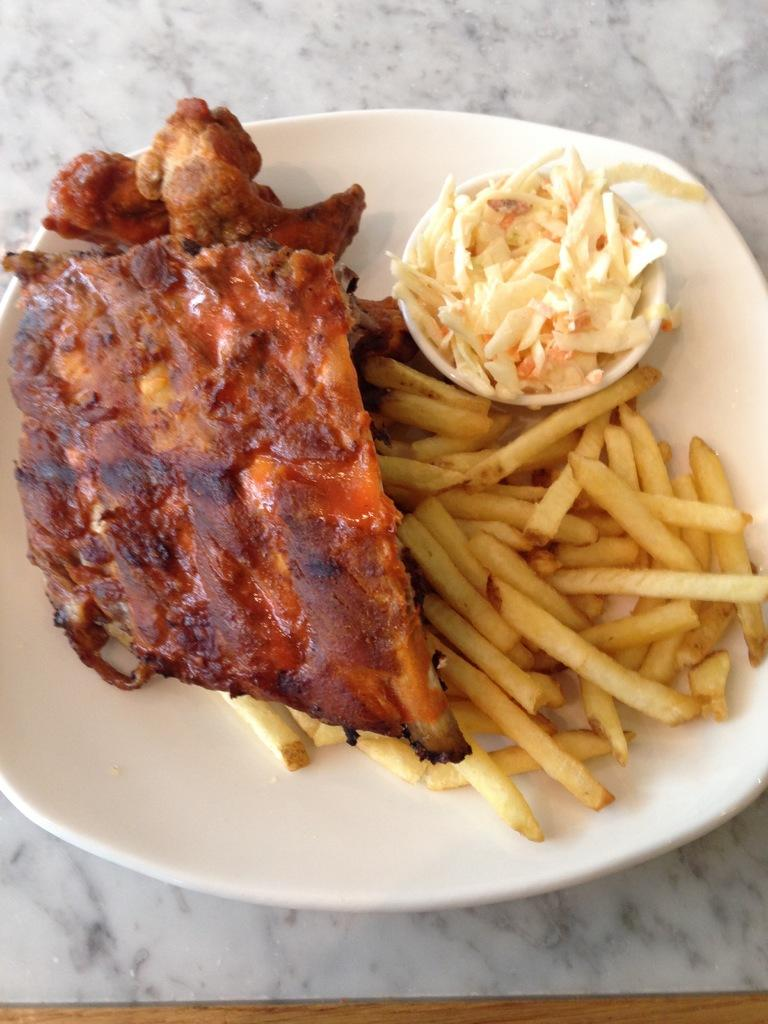What is located in the center of the image? There is a plate in the center of the image. What is on the plate? The plate contains food items. What type of ice can be seen melting on the plate in the image? There is no ice present on the plate in the image; it contains food items. 